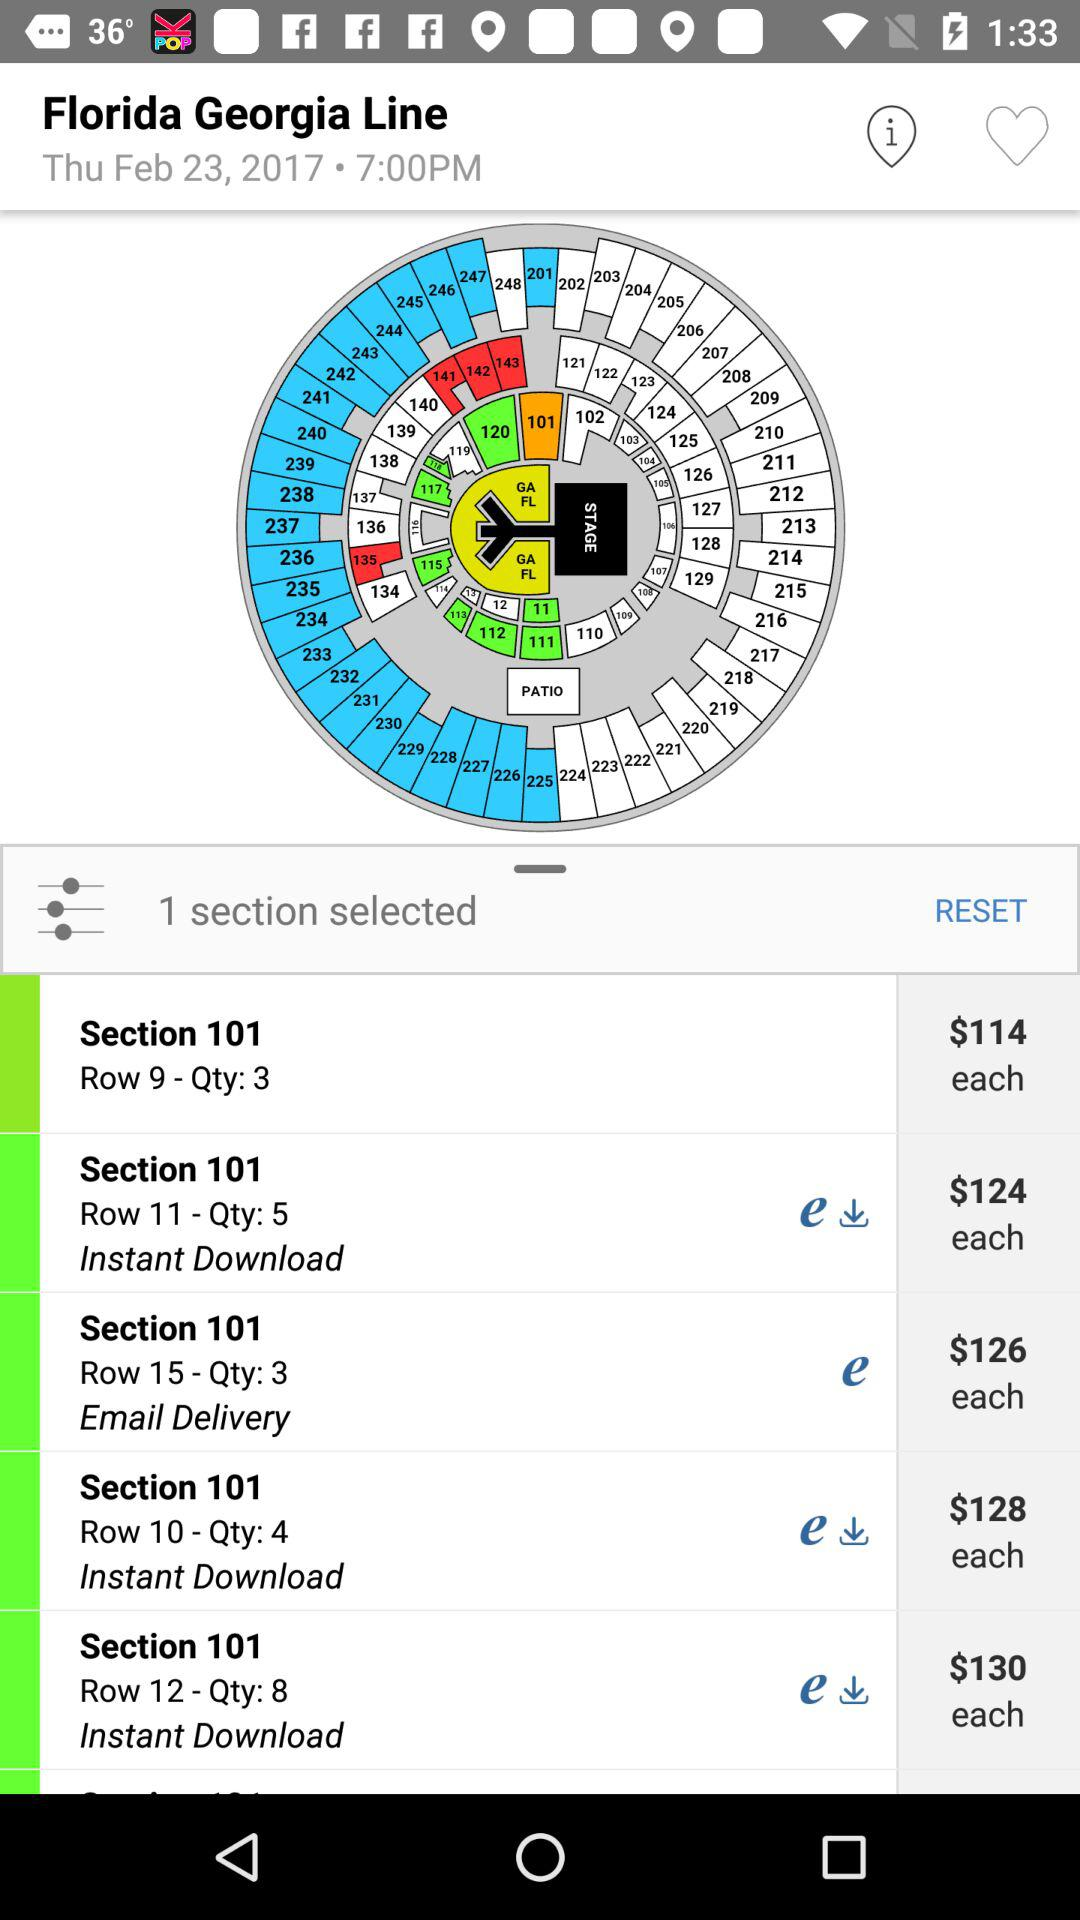In which currency price is selected? The price is selected in dollars. 